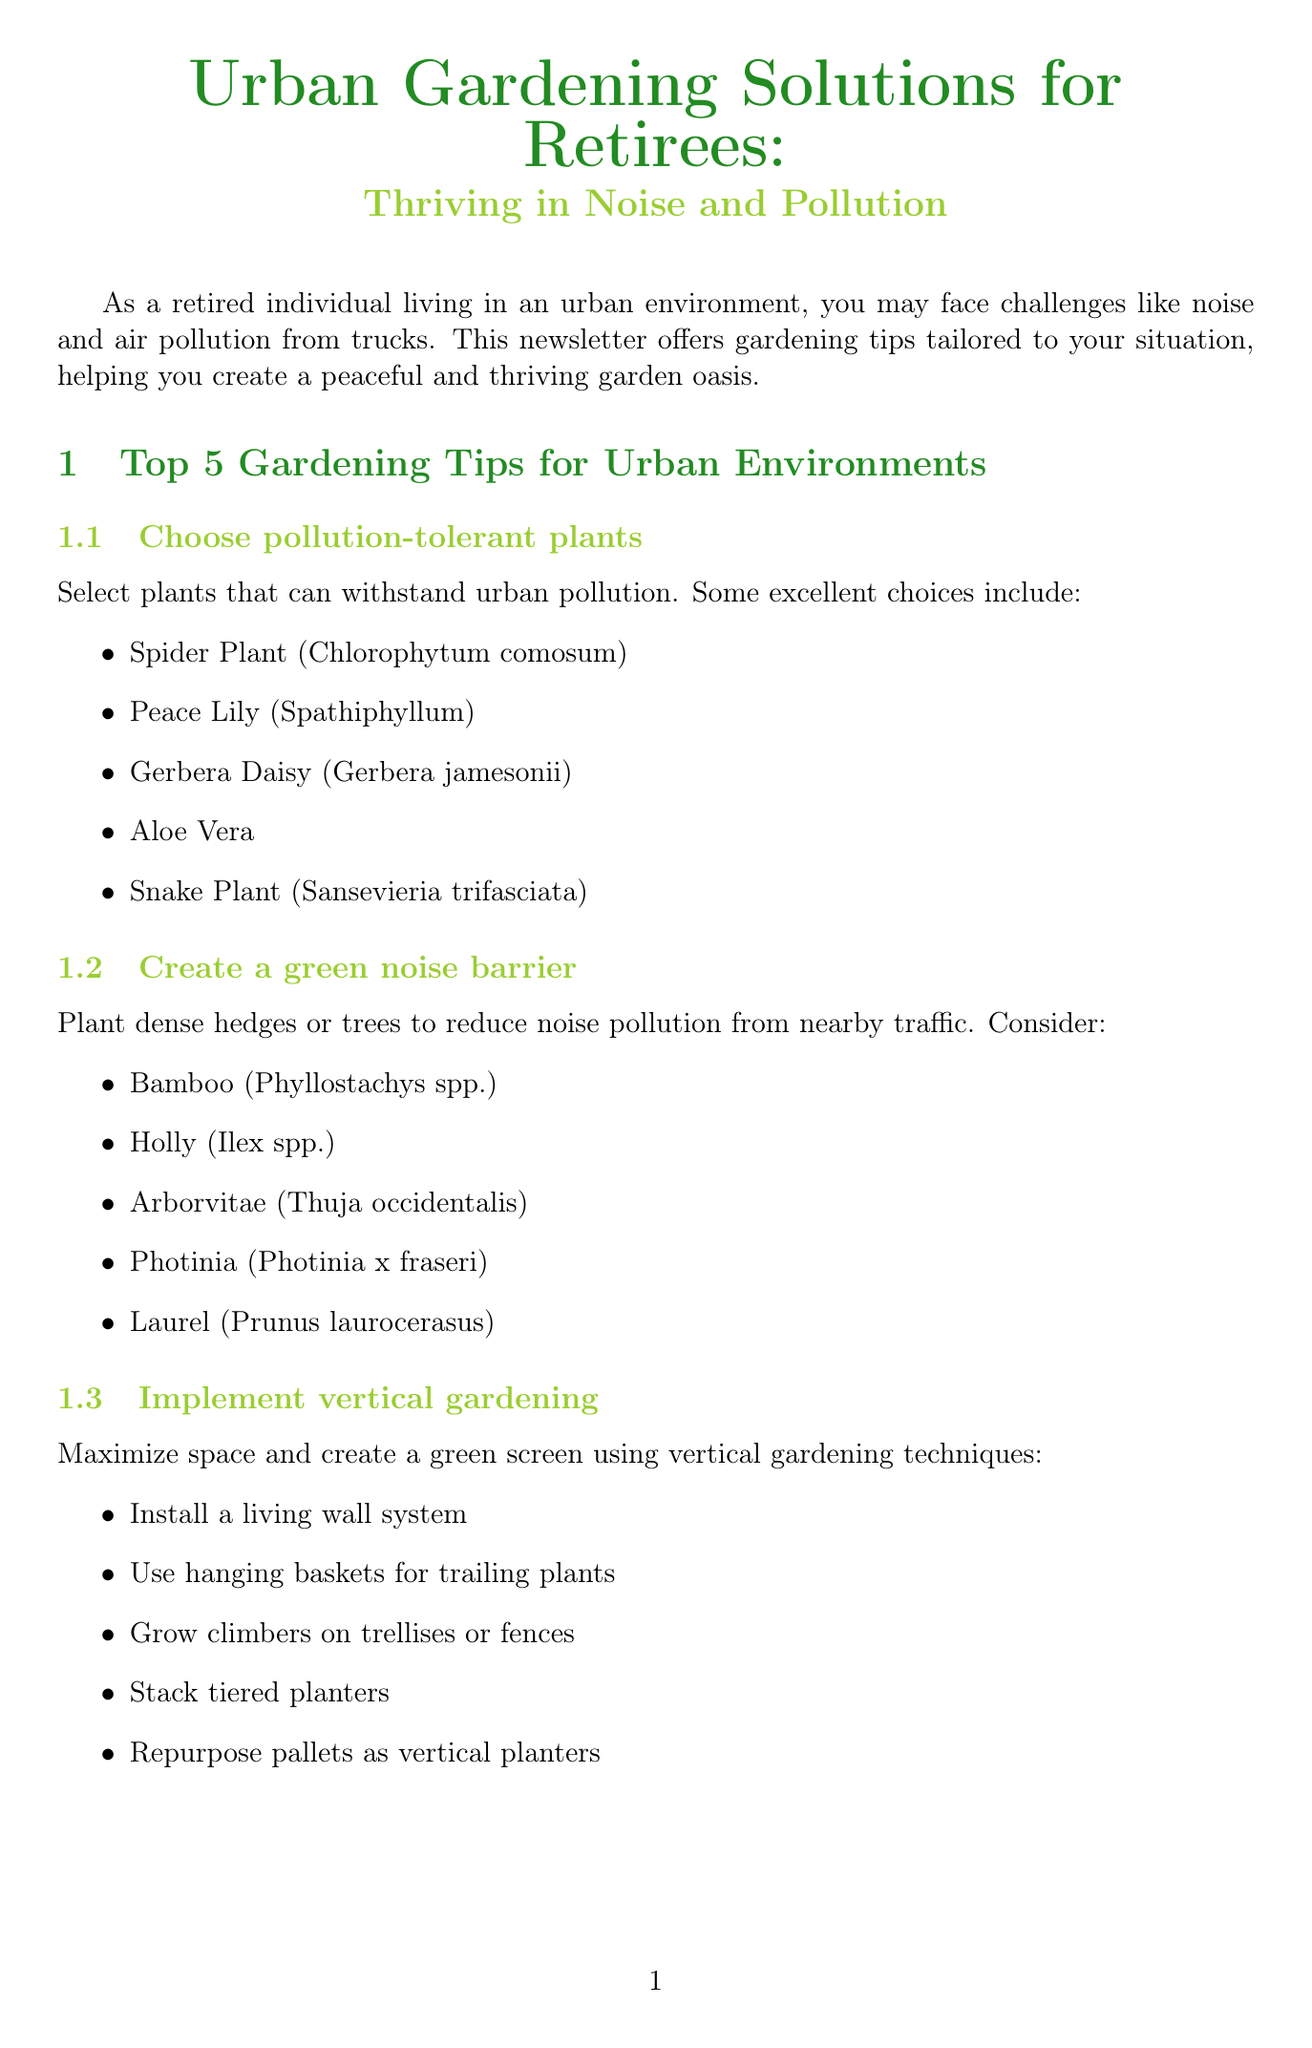What is the newsletter's title? The title is mentioned at the beginning of the document, summarizing the main theme with a focus on urban gardening for retirees.
Answer: Urban Gardening Solutions for Retirees: Thriving in Noise and Pollution How many gardening tips are listed? The number of tips is explicitly stated in the section heading and correlates with the content verbosity.
Answer: 5 Which plant is suggested for noise reduction? The document lists specific plants aimed at creating noise barriers, derived from the tip focused on that issue.
Answer: Bamboo What type of gardening technique helps maximize space? The tip section discusses vertical gardening techniques as a solution for limited space.
Answer: Vertical gardening What additional resource focuses on noise reduction? The document outlines several resources, one of which is explicitly titled about noise reduction landscaping strategies.
Answer: Noise Reduction Landscaping Guide Name one air-purifying plant mentioned. The document lists several plants known for air purification, providing a couple of examples in that section.
Answer: Boston Fern What is the purpose of container gardening? The description in the document indicates that container gardening is particularly useful for certain challenging environmental conditions.
Answer: Poor soil quality What is suggested to assess your garden's environment? The document provides a resource that helps gardeners monitor air quality to make informed plant choices.
Answer: Air quality monitoring tools 